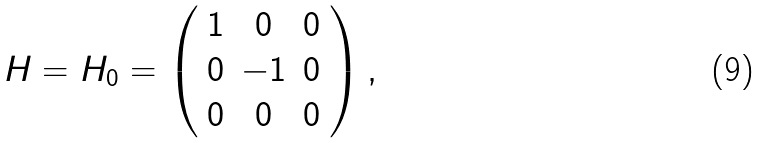<formula> <loc_0><loc_0><loc_500><loc_500>H = H _ { 0 } = \left ( \begin{array} { c c c } 1 & 0 & 0 \\ 0 & - 1 & 0 \\ 0 & 0 & 0 \end{array} \right ) ,</formula> 